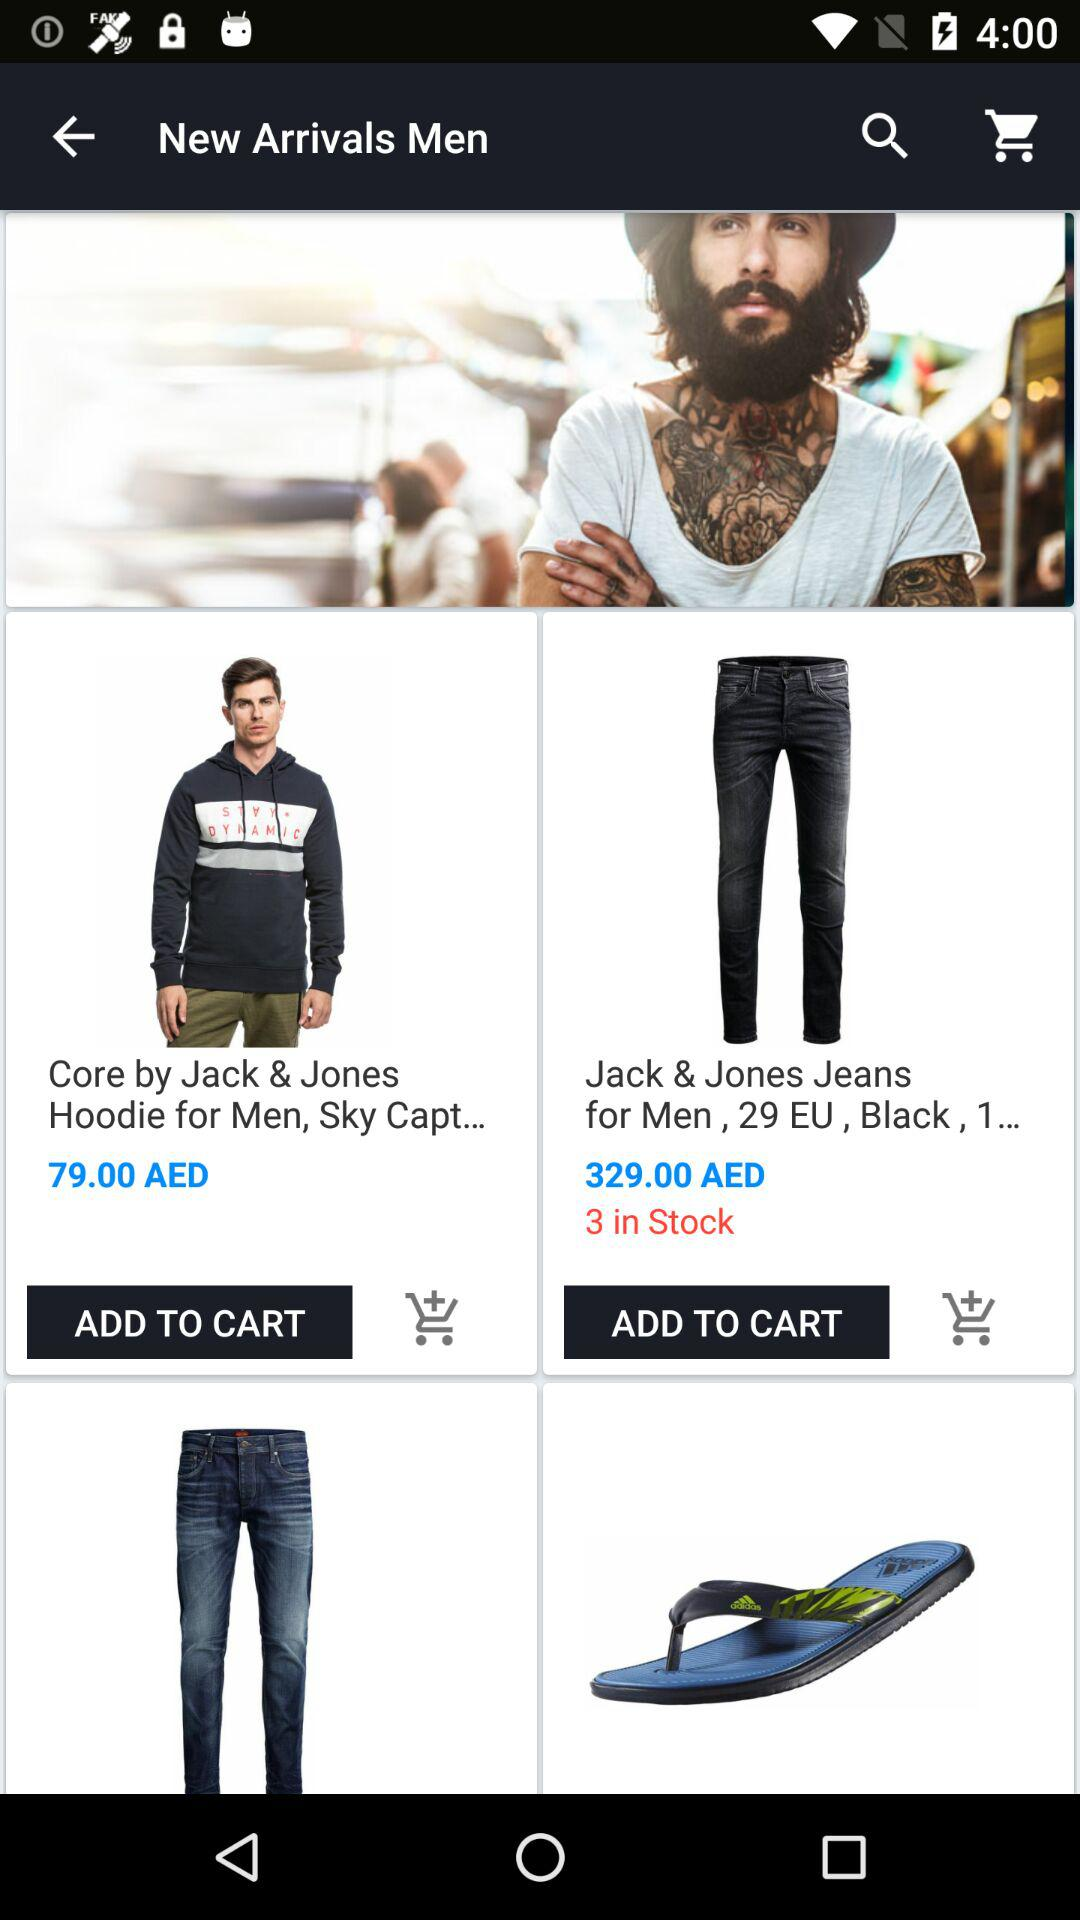What is the cost of the Jack and Jones hoodie for men? The cost of the Jack and Jones hoodie for men is 79.00 AED. 